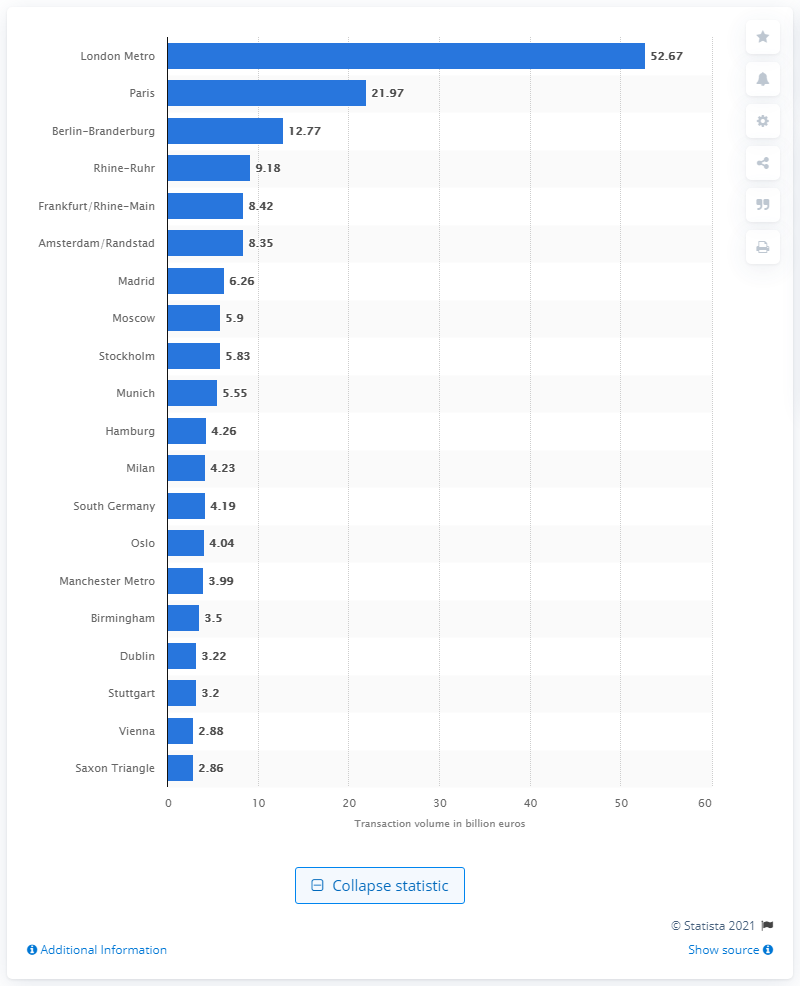Specify some key components in this picture. In January 2016, the transaction volume of London Metro was 52.67. According to a ranking in January 2016, London Metro was identified as the most active real estate market. 